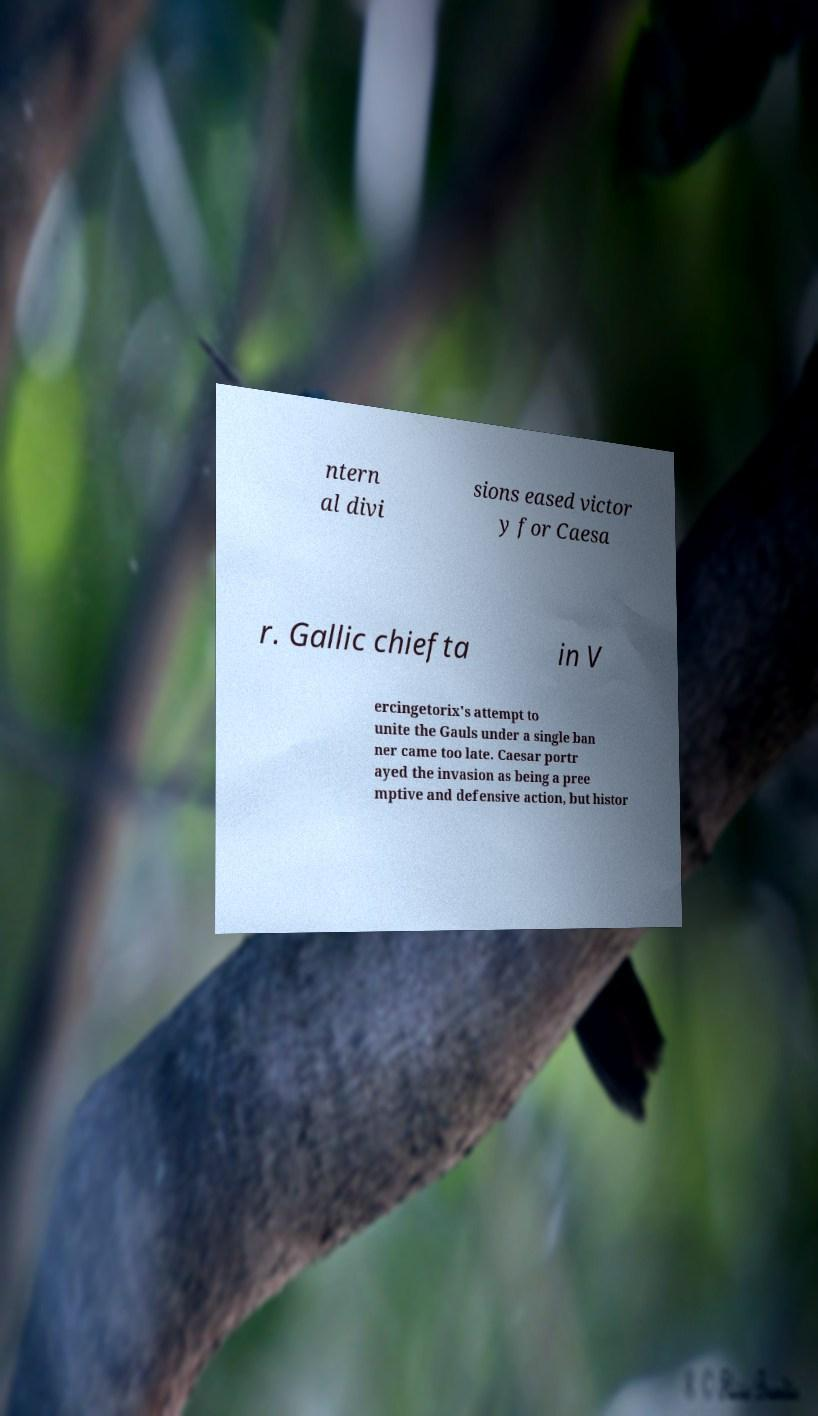There's text embedded in this image that I need extracted. Can you transcribe it verbatim? ntern al divi sions eased victor y for Caesa r. Gallic chiefta in V ercingetorix's attempt to unite the Gauls under a single ban ner came too late. Caesar portr ayed the invasion as being a pree mptive and defensive action, but histor 